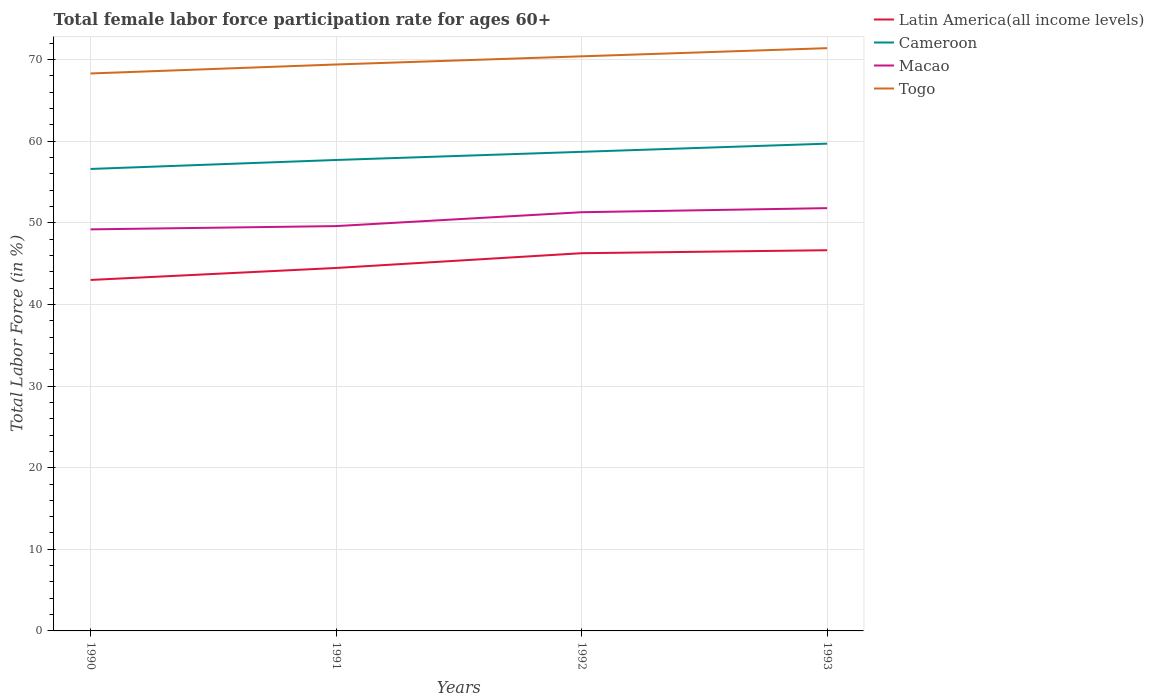Does the line corresponding to Togo intersect with the line corresponding to Latin America(all income levels)?
Ensure brevity in your answer.  No. Is the number of lines equal to the number of legend labels?
Your answer should be very brief. Yes. Across all years, what is the maximum female labor force participation rate in Togo?
Offer a very short reply. 68.3. In which year was the female labor force participation rate in Togo maximum?
Your response must be concise. 1990. What is the total female labor force participation rate in Macao in the graph?
Provide a succinct answer. -2.1. What is the difference between the highest and the second highest female labor force participation rate in Macao?
Provide a succinct answer. 2.6. What is the difference between the highest and the lowest female labor force participation rate in Macao?
Your answer should be very brief. 2. How many years are there in the graph?
Provide a short and direct response. 4. Are the values on the major ticks of Y-axis written in scientific E-notation?
Your answer should be compact. No. Does the graph contain grids?
Give a very brief answer. Yes. Where does the legend appear in the graph?
Make the answer very short. Top right. What is the title of the graph?
Make the answer very short. Total female labor force participation rate for ages 60+. Does "Czech Republic" appear as one of the legend labels in the graph?
Give a very brief answer. No. What is the label or title of the X-axis?
Keep it short and to the point. Years. What is the Total Labor Force (in %) of Latin America(all income levels) in 1990?
Ensure brevity in your answer.  43. What is the Total Labor Force (in %) of Cameroon in 1990?
Your answer should be very brief. 56.6. What is the Total Labor Force (in %) of Macao in 1990?
Ensure brevity in your answer.  49.2. What is the Total Labor Force (in %) of Togo in 1990?
Offer a very short reply. 68.3. What is the Total Labor Force (in %) of Latin America(all income levels) in 1991?
Provide a short and direct response. 44.47. What is the Total Labor Force (in %) in Cameroon in 1991?
Offer a terse response. 57.7. What is the Total Labor Force (in %) in Macao in 1991?
Make the answer very short. 49.6. What is the Total Labor Force (in %) in Togo in 1991?
Make the answer very short. 69.4. What is the Total Labor Force (in %) in Latin America(all income levels) in 1992?
Offer a very short reply. 46.28. What is the Total Labor Force (in %) of Cameroon in 1992?
Make the answer very short. 58.7. What is the Total Labor Force (in %) in Macao in 1992?
Offer a very short reply. 51.3. What is the Total Labor Force (in %) of Togo in 1992?
Ensure brevity in your answer.  70.4. What is the Total Labor Force (in %) of Latin America(all income levels) in 1993?
Provide a succinct answer. 46.64. What is the Total Labor Force (in %) in Cameroon in 1993?
Your answer should be very brief. 59.7. What is the Total Labor Force (in %) of Macao in 1993?
Give a very brief answer. 51.8. What is the Total Labor Force (in %) of Togo in 1993?
Offer a terse response. 71.4. Across all years, what is the maximum Total Labor Force (in %) in Latin America(all income levels)?
Provide a succinct answer. 46.64. Across all years, what is the maximum Total Labor Force (in %) of Cameroon?
Your answer should be very brief. 59.7. Across all years, what is the maximum Total Labor Force (in %) of Macao?
Your answer should be very brief. 51.8. Across all years, what is the maximum Total Labor Force (in %) in Togo?
Give a very brief answer. 71.4. Across all years, what is the minimum Total Labor Force (in %) of Latin America(all income levels)?
Keep it short and to the point. 43. Across all years, what is the minimum Total Labor Force (in %) in Cameroon?
Your response must be concise. 56.6. Across all years, what is the minimum Total Labor Force (in %) of Macao?
Ensure brevity in your answer.  49.2. Across all years, what is the minimum Total Labor Force (in %) in Togo?
Provide a succinct answer. 68.3. What is the total Total Labor Force (in %) in Latin America(all income levels) in the graph?
Keep it short and to the point. 180.39. What is the total Total Labor Force (in %) of Cameroon in the graph?
Keep it short and to the point. 232.7. What is the total Total Labor Force (in %) in Macao in the graph?
Provide a short and direct response. 201.9. What is the total Total Labor Force (in %) of Togo in the graph?
Your response must be concise. 279.5. What is the difference between the Total Labor Force (in %) in Latin America(all income levels) in 1990 and that in 1991?
Give a very brief answer. -1.47. What is the difference between the Total Labor Force (in %) in Togo in 1990 and that in 1991?
Make the answer very short. -1.1. What is the difference between the Total Labor Force (in %) of Latin America(all income levels) in 1990 and that in 1992?
Provide a succinct answer. -3.28. What is the difference between the Total Labor Force (in %) in Cameroon in 1990 and that in 1992?
Provide a succinct answer. -2.1. What is the difference between the Total Labor Force (in %) of Macao in 1990 and that in 1992?
Provide a succinct answer. -2.1. What is the difference between the Total Labor Force (in %) in Togo in 1990 and that in 1992?
Your answer should be very brief. -2.1. What is the difference between the Total Labor Force (in %) of Latin America(all income levels) in 1990 and that in 1993?
Offer a very short reply. -3.64. What is the difference between the Total Labor Force (in %) of Cameroon in 1990 and that in 1993?
Provide a succinct answer. -3.1. What is the difference between the Total Labor Force (in %) in Latin America(all income levels) in 1991 and that in 1992?
Provide a succinct answer. -1.81. What is the difference between the Total Labor Force (in %) of Togo in 1991 and that in 1992?
Keep it short and to the point. -1. What is the difference between the Total Labor Force (in %) in Latin America(all income levels) in 1991 and that in 1993?
Ensure brevity in your answer.  -2.17. What is the difference between the Total Labor Force (in %) of Togo in 1991 and that in 1993?
Your answer should be compact. -2. What is the difference between the Total Labor Force (in %) in Latin America(all income levels) in 1992 and that in 1993?
Your answer should be compact. -0.37. What is the difference between the Total Labor Force (in %) in Togo in 1992 and that in 1993?
Ensure brevity in your answer.  -1. What is the difference between the Total Labor Force (in %) of Latin America(all income levels) in 1990 and the Total Labor Force (in %) of Cameroon in 1991?
Your answer should be compact. -14.7. What is the difference between the Total Labor Force (in %) of Latin America(all income levels) in 1990 and the Total Labor Force (in %) of Macao in 1991?
Your answer should be compact. -6.6. What is the difference between the Total Labor Force (in %) of Latin America(all income levels) in 1990 and the Total Labor Force (in %) of Togo in 1991?
Provide a short and direct response. -26.4. What is the difference between the Total Labor Force (in %) of Cameroon in 1990 and the Total Labor Force (in %) of Macao in 1991?
Ensure brevity in your answer.  7. What is the difference between the Total Labor Force (in %) of Macao in 1990 and the Total Labor Force (in %) of Togo in 1991?
Offer a terse response. -20.2. What is the difference between the Total Labor Force (in %) of Latin America(all income levels) in 1990 and the Total Labor Force (in %) of Cameroon in 1992?
Ensure brevity in your answer.  -15.7. What is the difference between the Total Labor Force (in %) in Latin America(all income levels) in 1990 and the Total Labor Force (in %) in Macao in 1992?
Your response must be concise. -8.3. What is the difference between the Total Labor Force (in %) in Latin America(all income levels) in 1990 and the Total Labor Force (in %) in Togo in 1992?
Your answer should be compact. -27.4. What is the difference between the Total Labor Force (in %) in Macao in 1990 and the Total Labor Force (in %) in Togo in 1992?
Your answer should be compact. -21.2. What is the difference between the Total Labor Force (in %) in Latin America(all income levels) in 1990 and the Total Labor Force (in %) in Cameroon in 1993?
Offer a terse response. -16.7. What is the difference between the Total Labor Force (in %) of Latin America(all income levels) in 1990 and the Total Labor Force (in %) of Macao in 1993?
Give a very brief answer. -8.8. What is the difference between the Total Labor Force (in %) in Latin America(all income levels) in 1990 and the Total Labor Force (in %) in Togo in 1993?
Your answer should be compact. -28.4. What is the difference between the Total Labor Force (in %) of Cameroon in 1990 and the Total Labor Force (in %) of Macao in 1993?
Offer a terse response. 4.8. What is the difference between the Total Labor Force (in %) of Cameroon in 1990 and the Total Labor Force (in %) of Togo in 1993?
Ensure brevity in your answer.  -14.8. What is the difference between the Total Labor Force (in %) of Macao in 1990 and the Total Labor Force (in %) of Togo in 1993?
Your answer should be very brief. -22.2. What is the difference between the Total Labor Force (in %) in Latin America(all income levels) in 1991 and the Total Labor Force (in %) in Cameroon in 1992?
Offer a terse response. -14.23. What is the difference between the Total Labor Force (in %) of Latin America(all income levels) in 1991 and the Total Labor Force (in %) of Macao in 1992?
Provide a short and direct response. -6.83. What is the difference between the Total Labor Force (in %) of Latin America(all income levels) in 1991 and the Total Labor Force (in %) of Togo in 1992?
Ensure brevity in your answer.  -25.93. What is the difference between the Total Labor Force (in %) of Cameroon in 1991 and the Total Labor Force (in %) of Macao in 1992?
Offer a very short reply. 6.4. What is the difference between the Total Labor Force (in %) in Macao in 1991 and the Total Labor Force (in %) in Togo in 1992?
Provide a succinct answer. -20.8. What is the difference between the Total Labor Force (in %) of Latin America(all income levels) in 1991 and the Total Labor Force (in %) of Cameroon in 1993?
Ensure brevity in your answer.  -15.23. What is the difference between the Total Labor Force (in %) of Latin America(all income levels) in 1991 and the Total Labor Force (in %) of Macao in 1993?
Provide a succinct answer. -7.33. What is the difference between the Total Labor Force (in %) of Latin America(all income levels) in 1991 and the Total Labor Force (in %) of Togo in 1993?
Offer a very short reply. -26.93. What is the difference between the Total Labor Force (in %) of Cameroon in 1991 and the Total Labor Force (in %) of Macao in 1993?
Your response must be concise. 5.9. What is the difference between the Total Labor Force (in %) of Cameroon in 1991 and the Total Labor Force (in %) of Togo in 1993?
Provide a short and direct response. -13.7. What is the difference between the Total Labor Force (in %) of Macao in 1991 and the Total Labor Force (in %) of Togo in 1993?
Give a very brief answer. -21.8. What is the difference between the Total Labor Force (in %) of Latin America(all income levels) in 1992 and the Total Labor Force (in %) of Cameroon in 1993?
Give a very brief answer. -13.42. What is the difference between the Total Labor Force (in %) of Latin America(all income levels) in 1992 and the Total Labor Force (in %) of Macao in 1993?
Make the answer very short. -5.52. What is the difference between the Total Labor Force (in %) in Latin America(all income levels) in 1992 and the Total Labor Force (in %) in Togo in 1993?
Make the answer very short. -25.12. What is the difference between the Total Labor Force (in %) in Cameroon in 1992 and the Total Labor Force (in %) in Macao in 1993?
Your answer should be compact. 6.9. What is the difference between the Total Labor Force (in %) of Cameroon in 1992 and the Total Labor Force (in %) of Togo in 1993?
Make the answer very short. -12.7. What is the difference between the Total Labor Force (in %) in Macao in 1992 and the Total Labor Force (in %) in Togo in 1993?
Offer a very short reply. -20.1. What is the average Total Labor Force (in %) of Latin America(all income levels) per year?
Offer a very short reply. 45.1. What is the average Total Labor Force (in %) in Cameroon per year?
Provide a short and direct response. 58.17. What is the average Total Labor Force (in %) of Macao per year?
Provide a succinct answer. 50.48. What is the average Total Labor Force (in %) in Togo per year?
Offer a terse response. 69.88. In the year 1990, what is the difference between the Total Labor Force (in %) in Latin America(all income levels) and Total Labor Force (in %) in Cameroon?
Provide a short and direct response. -13.6. In the year 1990, what is the difference between the Total Labor Force (in %) in Latin America(all income levels) and Total Labor Force (in %) in Macao?
Offer a very short reply. -6.2. In the year 1990, what is the difference between the Total Labor Force (in %) of Latin America(all income levels) and Total Labor Force (in %) of Togo?
Offer a terse response. -25.3. In the year 1990, what is the difference between the Total Labor Force (in %) in Cameroon and Total Labor Force (in %) in Macao?
Your response must be concise. 7.4. In the year 1990, what is the difference between the Total Labor Force (in %) of Macao and Total Labor Force (in %) of Togo?
Provide a succinct answer. -19.1. In the year 1991, what is the difference between the Total Labor Force (in %) of Latin America(all income levels) and Total Labor Force (in %) of Cameroon?
Provide a succinct answer. -13.23. In the year 1991, what is the difference between the Total Labor Force (in %) of Latin America(all income levels) and Total Labor Force (in %) of Macao?
Your answer should be very brief. -5.13. In the year 1991, what is the difference between the Total Labor Force (in %) of Latin America(all income levels) and Total Labor Force (in %) of Togo?
Offer a terse response. -24.93. In the year 1991, what is the difference between the Total Labor Force (in %) in Cameroon and Total Labor Force (in %) in Macao?
Provide a short and direct response. 8.1. In the year 1991, what is the difference between the Total Labor Force (in %) of Cameroon and Total Labor Force (in %) of Togo?
Provide a succinct answer. -11.7. In the year 1991, what is the difference between the Total Labor Force (in %) in Macao and Total Labor Force (in %) in Togo?
Provide a short and direct response. -19.8. In the year 1992, what is the difference between the Total Labor Force (in %) of Latin America(all income levels) and Total Labor Force (in %) of Cameroon?
Make the answer very short. -12.42. In the year 1992, what is the difference between the Total Labor Force (in %) in Latin America(all income levels) and Total Labor Force (in %) in Macao?
Your response must be concise. -5.02. In the year 1992, what is the difference between the Total Labor Force (in %) in Latin America(all income levels) and Total Labor Force (in %) in Togo?
Ensure brevity in your answer.  -24.12. In the year 1992, what is the difference between the Total Labor Force (in %) in Cameroon and Total Labor Force (in %) in Togo?
Offer a terse response. -11.7. In the year 1992, what is the difference between the Total Labor Force (in %) of Macao and Total Labor Force (in %) of Togo?
Your answer should be very brief. -19.1. In the year 1993, what is the difference between the Total Labor Force (in %) of Latin America(all income levels) and Total Labor Force (in %) of Cameroon?
Provide a short and direct response. -13.06. In the year 1993, what is the difference between the Total Labor Force (in %) of Latin America(all income levels) and Total Labor Force (in %) of Macao?
Provide a succinct answer. -5.16. In the year 1993, what is the difference between the Total Labor Force (in %) of Latin America(all income levels) and Total Labor Force (in %) of Togo?
Make the answer very short. -24.76. In the year 1993, what is the difference between the Total Labor Force (in %) in Macao and Total Labor Force (in %) in Togo?
Provide a short and direct response. -19.6. What is the ratio of the Total Labor Force (in %) in Latin America(all income levels) in 1990 to that in 1991?
Offer a terse response. 0.97. What is the ratio of the Total Labor Force (in %) in Cameroon in 1990 to that in 1991?
Provide a succinct answer. 0.98. What is the ratio of the Total Labor Force (in %) in Togo in 1990 to that in 1991?
Keep it short and to the point. 0.98. What is the ratio of the Total Labor Force (in %) in Latin America(all income levels) in 1990 to that in 1992?
Provide a short and direct response. 0.93. What is the ratio of the Total Labor Force (in %) in Cameroon in 1990 to that in 1992?
Your answer should be very brief. 0.96. What is the ratio of the Total Labor Force (in %) of Macao in 1990 to that in 1992?
Your answer should be compact. 0.96. What is the ratio of the Total Labor Force (in %) of Togo in 1990 to that in 1992?
Offer a very short reply. 0.97. What is the ratio of the Total Labor Force (in %) in Latin America(all income levels) in 1990 to that in 1993?
Offer a very short reply. 0.92. What is the ratio of the Total Labor Force (in %) of Cameroon in 1990 to that in 1993?
Your response must be concise. 0.95. What is the ratio of the Total Labor Force (in %) in Macao in 1990 to that in 1993?
Ensure brevity in your answer.  0.95. What is the ratio of the Total Labor Force (in %) in Togo in 1990 to that in 1993?
Offer a very short reply. 0.96. What is the ratio of the Total Labor Force (in %) of Latin America(all income levels) in 1991 to that in 1992?
Ensure brevity in your answer.  0.96. What is the ratio of the Total Labor Force (in %) of Cameroon in 1991 to that in 1992?
Make the answer very short. 0.98. What is the ratio of the Total Labor Force (in %) in Macao in 1991 to that in 1992?
Your response must be concise. 0.97. What is the ratio of the Total Labor Force (in %) in Togo in 1991 to that in 1992?
Provide a short and direct response. 0.99. What is the ratio of the Total Labor Force (in %) of Latin America(all income levels) in 1991 to that in 1993?
Your response must be concise. 0.95. What is the ratio of the Total Labor Force (in %) of Cameroon in 1991 to that in 1993?
Offer a very short reply. 0.97. What is the ratio of the Total Labor Force (in %) of Macao in 1991 to that in 1993?
Provide a short and direct response. 0.96. What is the ratio of the Total Labor Force (in %) in Latin America(all income levels) in 1992 to that in 1993?
Offer a terse response. 0.99. What is the ratio of the Total Labor Force (in %) in Cameroon in 1992 to that in 1993?
Offer a terse response. 0.98. What is the ratio of the Total Labor Force (in %) of Macao in 1992 to that in 1993?
Provide a succinct answer. 0.99. What is the ratio of the Total Labor Force (in %) in Togo in 1992 to that in 1993?
Ensure brevity in your answer.  0.99. What is the difference between the highest and the second highest Total Labor Force (in %) of Latin America(all income levels)?
Keep it short and to the point. 0.37. What is the difference between the highest and the second highest Total Labor Force (in %) in Cameroon?
Provide a succinct answer. 1. What is the difference between the highest and the second highest Total Labor Force (in %) in Macao?
Ensure brevity in your answer.  0.5. What is the difference between the highest and the second highest Total Labor Force (in %) of Togo?
Your response must be concise. 1. What is the difference between the highest and the lowest Total Labor Force (in %) of Latin America(all income levels)?
Your response must be concise. 3.64. What is the difference between the highest and the lowest Total Labor Force (in %) of Cameroon?
Your response must be concise. 3.1. What is the difference between the highest and the lowest Total Labor Force (in %) of Togo?
Your answer should be compact. 3.1. 